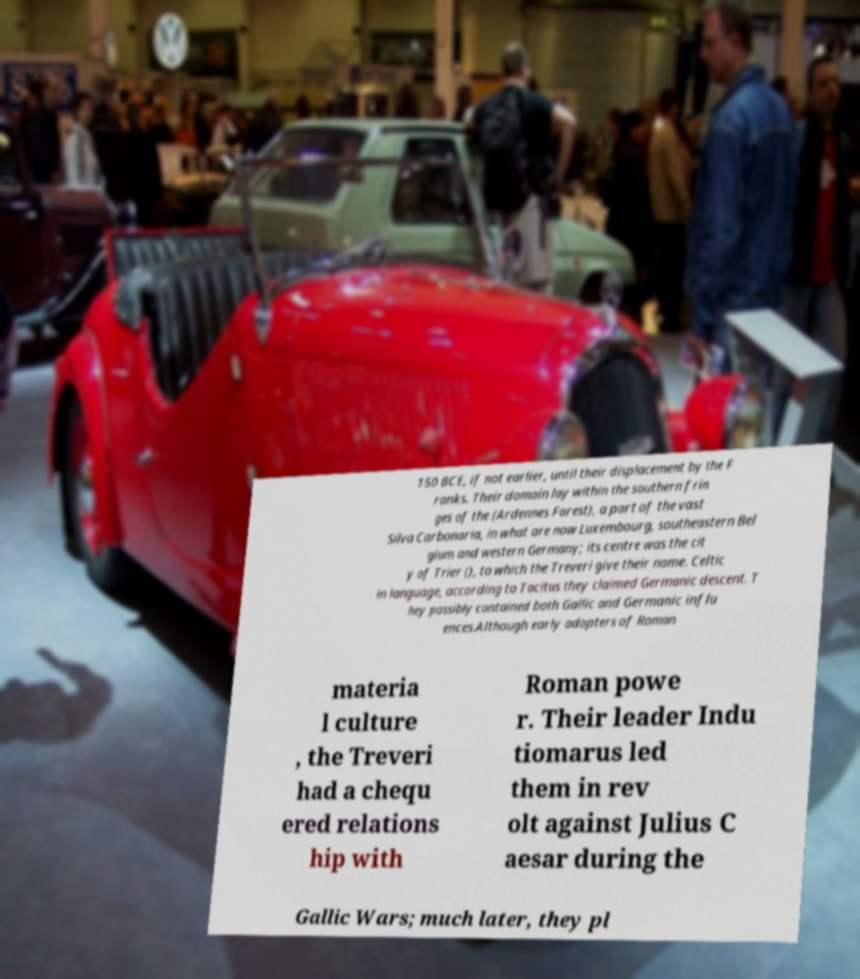What messages or text are displayed in this image? I need them in a readable, typed format. 150 BCE, if not earlier, until their displacement by the F ranks. Their domain lay within the southern frin ges of the (Ardennes Forest), a part of the vast Silva Carbonaria, in what are now Luxembourg, southeastern Bel gium and western Germany; its centre was the cit y of Trier (), to which the Treveri give their name. Celtic in language, according to Tacitus they claimed Germanic descent. T hey possibly contained both Gallic and Germanic influ ences.Although early adopters of Roman materia l culture , the Treveri had a chequ ered relations hip with Roman powe r. Their leader Indu tiomarus led them in rev olt against Julius C aesar during the Gallic Wars; much later, they pl 